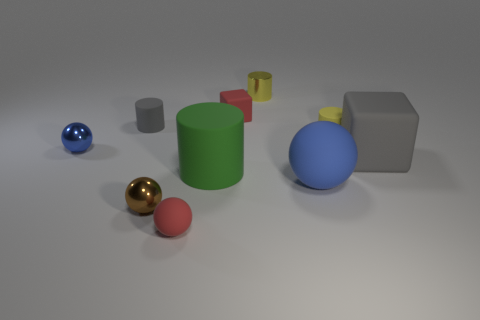Subtract all small balls. How many balls are left? 1 Subtract all gray blocks. How many blocks are left? 1 Subtract 1 cylinders. How many cylinders are left? 3 Subtract all gray matte cylinders. Subtract all blue balls. How many objects are left? 7 Add 8 tiny red blocks. How many tiny red blocks are left? 9 Add 4 small gray rubber things. How many small gray rubber things exist? 5 Subtract 0 yellow spheres. How many objects are left? 10 Subtract all blocks. How many objects are left? 8 Subtract all red balls. Subtract all brown blocks. How many balls are left? 3 Subtract all purple spheres. How many purple cubes are left? 0 